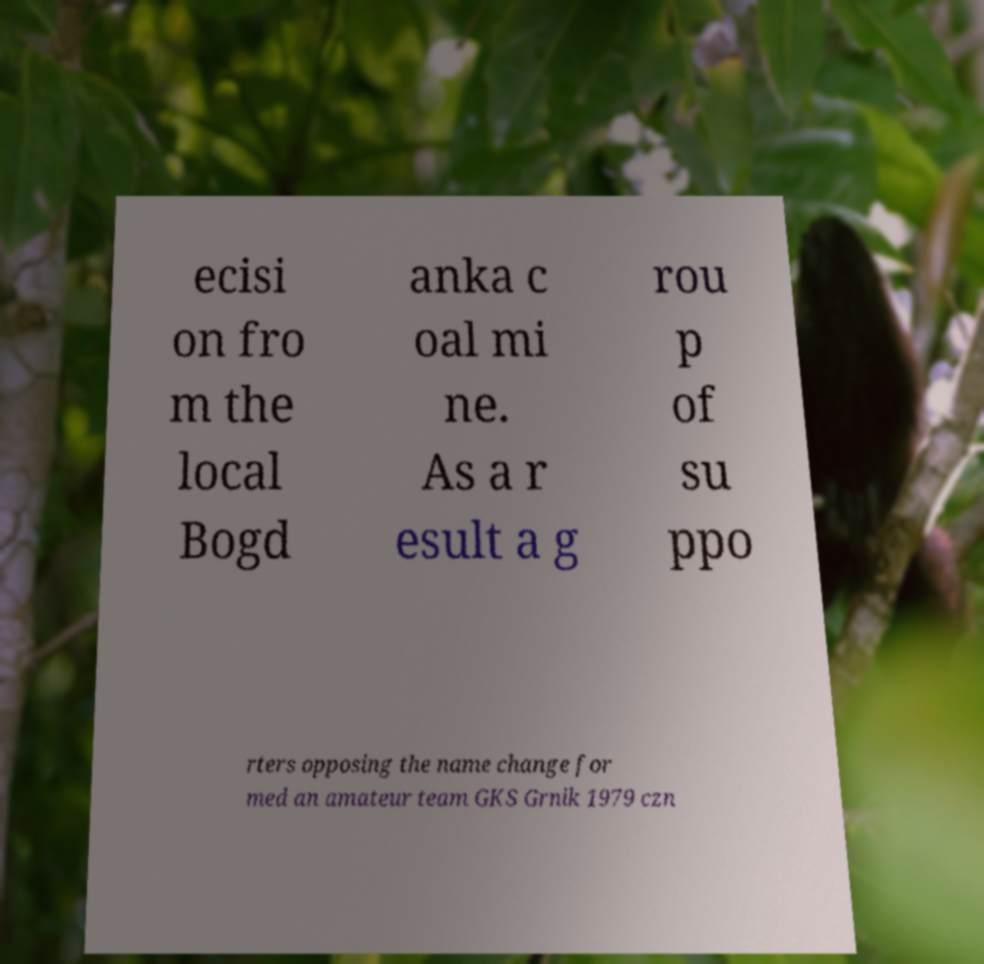Can you accurately transcribe the text from the provided image for me? ecisi on fro m the local Bogd anka c oal mi ne. As a r esult a g rou p of su ppo rters opposing the name change for med an amateur team GKS Grnik 1979 czn 